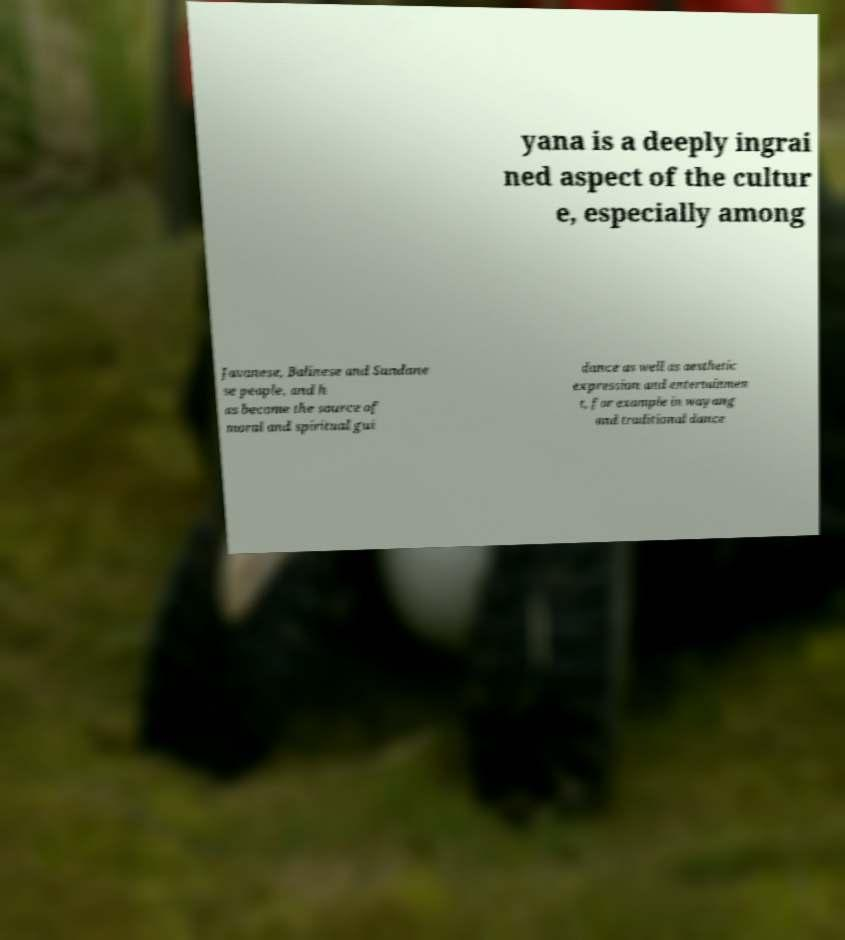Could you assist in decoding the text presented in this image and type it out clearly? yana is a deeply ingrai ned aspect of the cultur e, especially among Javanese, Balinese and Sundane se people, and h as become the source of moral and spiritual gui dance as well as aesthetic expression and entertainmen t, for example in wayang and traditional dance 